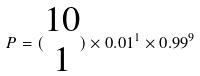<formula> <loc_0><loc_0><loc_500><loc_500>P = ( \begin{matrix} 1 0 \\ 1 \end{matrix} ) \times 0 . 0 1 ^ { 1 } \times 0 . 9 9 ^ { 9 }</formula> 